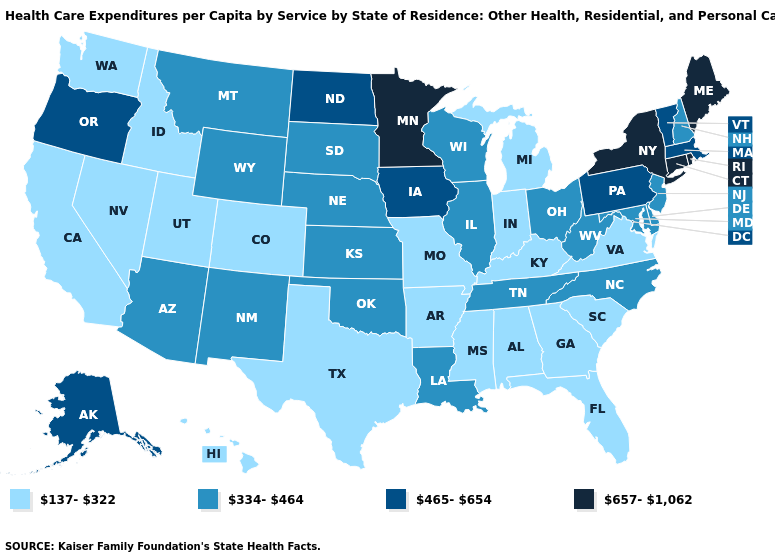Does New Hampshire have the highest value in the Northeast?
Concise answer only. No. Name the states that have a value in the range 137-322?
Short answer required. Alabama, Arkansas, California, Colorado, Florida, Georgia, Hawaii, Idaho, Indiana, Kentucky, Michigan, Mississippi, Missouri, Nevada, South Carolina, Texas, Utah, Virginia, Washington. Does Connecticut have a higher value than Colorado?
Give a very brief answer. Yes. Does New York have the highest value in the Northeast?
Quick response, please. Yes. How many symbols are there in the legend?
Answer briefly. 4. What is the lowest value in states that border Nevada?
Concise answer only. 137-322. What is the highest value in states that border Kentucky?
Quick response, please. 334-464. What is the value of Maine?
Answer briefly. 657-1,062. What is the lowest value in the USA?
Keep it brief. 137-322. What is the value of Wyoming?
Keep it brief. 334-464. Name the states that have a value in the range 465-654?
Concise answer only. Alaska, Iowa, Massachusetts, North Dakota, Oregon, Pennsylvania, Vermont. Does Vermont have a lower value than Connecticut?
Short answer required. Yes. Is the legend a continuous bar?
Keep it brief. No. What is the value of Iowa?
Concise answer only. 465-654. 